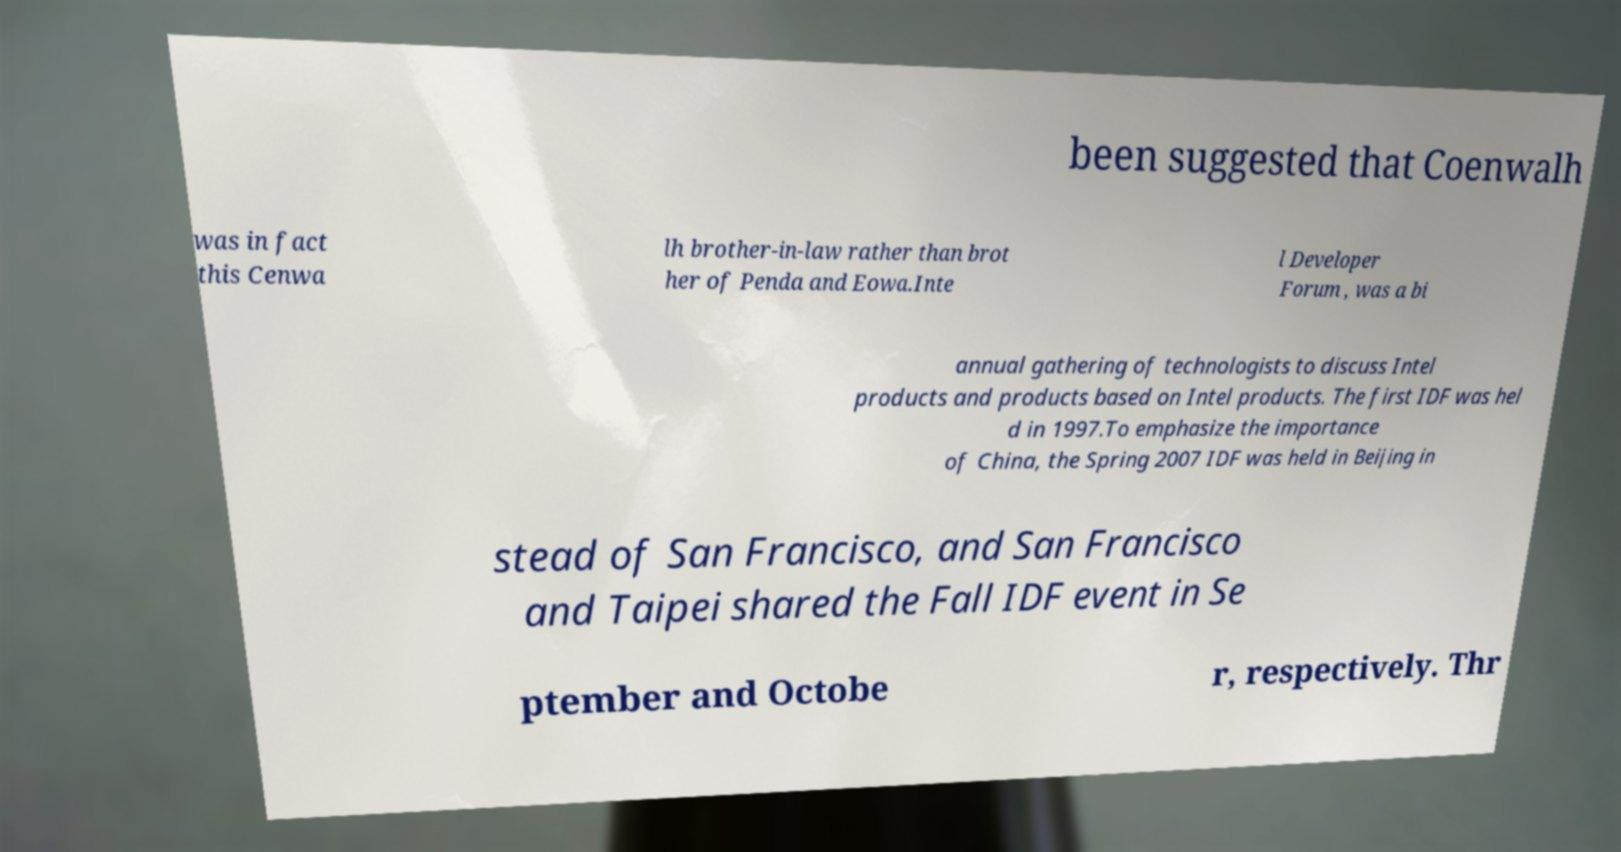For documentation purposes, I need the text within this image transcribed. Could you provide that? been suggested that Coenwalh was in fact this Cenwa lh brother-in-law rather than brot her of Penda and Eowa.Inte l Developer Forum , was a bi annual gathering of technologists to discuss Intel products and products based on Intel products. The first IDF was hel d in 1997.To emphasize the importance of China, the Spring 2007 IDF was held in Beijing in stead of San Francisco, and San Francisco and Taipei shared the Fall IDF event in Se ptember and Octobe r, respectively. Thr 